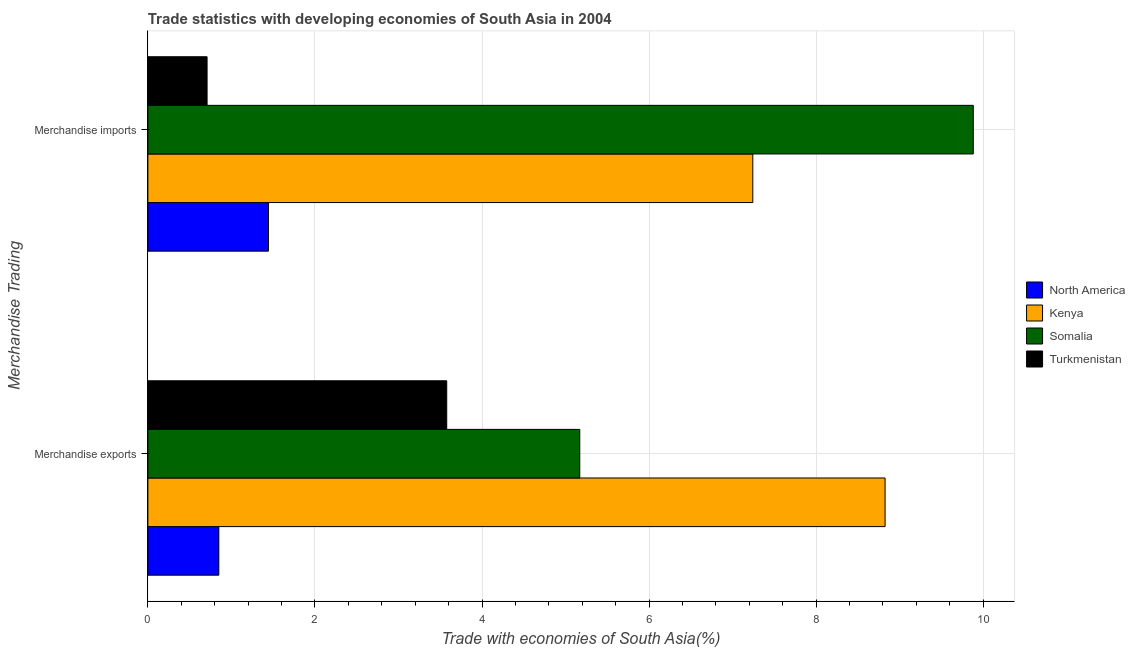How many different coloured bars are there?
Give a very brief answer. 4. How many groups of bars are there?
Make the answer very short. 2. How many bars are there on the 2nd tick from the bottom?
Offer a terse response. 4. What is the label of the 2nd group of bars from the top?
Make the answer very short. Merchandise exports. What is the merchandise exports in Turkmenistan?
Your answer should be very brief. 3.58. Across all countries, what is the maximum merchandise imports?
Give a very brief answer. 9.88. Across all countries, what is the minimum merchandise imports?
Offer a terse response. 0.71. In which country was the merchandise imports maximum?
Keep it short and to the point. Somalia. In which country was the merchandise imports minimum?
Make the answer very short. Turkmenistan. What is the total merchandise exports in the graph?
Provide a short and direct response. 18.42. What is the difference between the merchandise exports in Kenya and that in Somalia?
Provide a short and direct response. 3.65. What is the difference between the merchandise imports in North America and the merchandise exports in Turkmenistan?
Provide a short and direct response. -2.13. What is the average merchandise imports per country?
Offer a terse response. 4.82. What is the difference between the merchandise exports and merchandise imports in Somalia?
Give a very brief answer. -4.71. In how many countries, is the merchandise imports greater than 4.4 %?
Offer a very short reply. 2. What is the ratio of the merchandise exports in Kenya to that in Turkmenistan?
Keep it short and to the point. 2.47. Is the merchandise imports in Kenya less than that in North America?
Your answer should be very brief. No. What does the 4th bar from the bottom in Merchandise imports represents?
Your answer should be very brief. Turkmenistan. What is the difference between two consecutive major ticks on the X-axis?
Your answer should be very brief. 2. Does the graph contain any zero values?
Offer a very short reply. No. Does the graph contain grids?
Ensure brevity in your answer.  Yes. Where does the legend appear in the graph?
Keep it short and to the point. Center right. How many legend labels are there?
Your answer should be very brief. 4. What is the title of the graph?
Offer a terse response. Trade statistics with developing economies of South Asia in 2004. What is the label or title of the X-axis?
Your answer should be very brief. Trade with economies of South Asia(%). What is the label or title of the Y-axis?
Offer a terse response. Merchandise Trading. What is the Trade with economies of South Asia(%) of North America in Merchandise exports?
Your answer should be compact. 0.85. What is the Trade with economies of South Asia(%) of Kenya in Merchandise exports?
Provide a short and direct response. 8.83. What is the Trade with economies of South Asia(%) in Somalia in Merchandise exports?
Your response must be concise. 5.17. What is the Trade with economies of South Asia(%) of Turkmenistan in Merchandise exports?
Provide a succinct answer. 3.58. What is the Trade with economies of South Asia(%) in North America in Merchandise imports?
Your answer should be compact. 1.44. What is the Trade with economies of South Asia(%) in Kenya in Merchandise imports?
Your answer should be very brief. 7.24. What is the Trade with economies of South Asia(%) in Somalia in Merchandise imports?
Provide a succinct answer. 9.88. What is the Trade with economies of South Asia(%) in Turkmenistan in Merchandise imports?
Provide a succinct answer. 0.71. Across all Merchandise Trading, what is the maximum Trade with economies of South Asia(%) in North America?
Your response must be concise. 1.44. Across all Merchandise Trading, what is the maximum Trade with economies of South Asia(%) of Kenya?
Offer a terse response. 8.83. Across all Merchandise Trading, what is the maximum Trade with economies of South Asia(%) of Somalia?
Offer a terse response. 9.88. Across all Merchandise Trading, what is the maximum Trade with economies of South Asia(%) of Turkmenistan?
Your answer should be compact. 3.58. Across all Merchandise Trading, what is the minimum Trade with economies of South Asia(%) in North America?
Offer a terse response. 0.85. Across all Merchandise Trading, what is the minimum Trade with economies of South Asia(%) in Kenya?
Keep it short and to the point. 7.24. Across all Merchandise Trading, what is the minimum Trade with economies of South Asia(%) of Somalia?
Your response must be concise. 5.17. Across all Merchandise Trading, what is the minimum Trade with economies of South Asia(%) of Turkmenistan?
Ensure brevity in your answer.  0.71. What is the total Trade with economies of South Asia(%) in North America in the graph?
Provide a succinct answer. 2.29. What is the total Trade with economies of South Asia(%) of Kenya in the graph?
Offer a very short reply. 16.07. What is the total Trade with economies of South Asia(%) of Somalia in the graph?
Offer a very short reply. 15.05. What is the total Trade with economies of South Asia(%) in Turkmenistan in the graph?
Your answer should be compact. 4.29. What is the difference between the Trade with economies of South Asia(%) in North America in Merchandise exports and that in Merchandise imports?
Offer a very short reply. -0.59. What is the difference between the Trade with economies of South Asia(%) of Kenya in Merchandise exports and that in Merchandise imports?
Ensure brevity in your answer.  1.58. What is the difference between the Trade with economies of South Asia(%) in Somalia in Merchandise exports and that in Merchandise imports?
Your response must be concise. -4.71. What is the difference between the Trade with economies of South Asia(%) of Turkmenistan in Merchandise exports and that in Merchandise imports?
Give a very brief answer. 2.87. What is the difference between the Trade with economies of South Asia(%) in North America in Merchandise exports and the Trade with economies of South Asia(%) in Kenya in Merchandise imports?
Your answer should be compact. -6.39. What is the difference between the Trade with economies of South Asia(%) in North America in Merchandise exports and the Trade with economies of South Asia(%) in Somalia in Merchandise imports?
Offer a terse response. -9.03. What is the difference between the Trade with economies of South Asia(%) of North America in Merchandise exports and the Trade with economies of South Asia(%) of Turkmenistan in Merchandise imports?
Offer a very short reply. 0.14. What is the difference between the Trade with economies of South Asia(%) in Kenya in Merchandise exports and the Trade with economies of South Asia(%) in Somalia in Merchandise imports?
Provide a short and direct response. -1.06. What is the difference between the Trade with economies of South Asia(%) in Kenya in Merchandise exports and the Trade with economies of South Asia(%) in Turkmenistan in Merchandise imports?
Provide a short and direct response. 8.12. What is the difference between the Trade with economies of South Asia(%) in Somalia in Merchandise exports and the Trade with economies of South Asia(%) in Turkmenistan in Merchandise imports?
Provide a succinct answer. 4.46. What is the average Trade with economies of South Asia(%) of North America per Merchandise Trading?
Your response must be concise. 1.15. What is the average Trade with economies of South Asia(%) in Kenya per Merchandise Trading?
Make the answer very short. 8.03. What is the average Trade with economies of South Asia(%) of Somalia per Merchandise Trading?
Provide a succinct answer. 7.53. What is the average Trade with economies of South Asia(%) in Turkmenistan per Merchandise Trading?
Offer a very short reply. 2.14. What is the difference between the Trade with economies of South Asia(%) in North America and Trade with economies of South Asia(%) in Kenya in Merchandise exports?
Provide a short and direct response. -7.98. What is the difference between the Trade with economies of South Asia(%) of North America and Trade with economies of South Asia(%) of Somalia in Merchandise exports?
Your response must be concise. -4.32. What is the difference between the Trade with economies of South Asia(%) in North America and Trade with economies of South Asia(%) in Turkmenistan in Merchandise exports?
Keep it short and to the point. -2.73. What is the difference between the Trade with economies of South Asia(%) of Kenya and Trade with economies of South Asia(%) of Somalia in Merchandise exports?
Your answer should be very brief. 3.65. What is the difference between the Trade with economies of South Asia(%) in Kenya and Trade with economies of South Asia(%) in Turkmenistan in Merchandise exports?
Make the answer very short. 5.25. What is the difference between the Trade with economies of South Asia(%) of Somalia and Trade with economies of South Asia(%) of Turkmenistan in Merchandise exports?
Provide a short and direct response. 1.59. What is the difference between the Trade with economies of South Asia(%) in North America and Trade with economies of South Asia(%) in Kenya in Merchandise imports?
Give a very brief answer. -5.8. What is the difference between the Trade with economies of South Asia(%) in North America and Trade with economies of South Asia(%) in Somalia in Merchandise imports?
Provide a short and direct response. -8.44. What is the difference between the Trade with economies of South Asia(%) of North America and Trade with economies of South Asia(%) of Turkmenistan in Merchandise imports?
Your response must be concise. 0.73. What is the difference between the Trade with economies of South Asia(%) of Kenya and Trade with economies of South Asia(%) of Somalia in Merchandise imports?
Ensure brevity in your answer.  -2.64. What is the difference between the Trade with economies of South Asia(%) in Kenya and Trade with economies of South Asia(%) in Turkmenistan in Merchandise imports?
Give a very brief answer. 6.53. What is the difference between the Trade with economies of South Asia(%) in Somalia and Trade with economies of South Asia(%) in Turkmenistan in Merchandise imports?
Offer a terse response. 9.17. What is the ratio of the Trade with economies of South Asia(%) in North America in Merchandise exports to that in Merchandise imports?
Your response must be concise. 0.59. What is the ratio of the Trade with economies of South Asia(%) of Kenya in Merchandise exports to that in Merchandise imports?
Your answer should be compact. 1.22. What is the ratio of the Trade with economies of South Asia(%) in Somalia in Merchandise exports to that in Merchandise imports?
Offer a terse response. 0.52. What is the ratio of the Trade with economies of South Asia(%) of Turkmenistan in Merchandise exports to that in Merchandise imports?
Keep it short and to the point. 5.05. What is the difference between the highest and the second highest Trade with economies of South Asia(%) in North America?
Your answer should be very brief. 0.59. What is the difference between the highest and the second highest Trade with economies of South Asia(%) in Kenya?
Your response must be concise. 1.58. What is the difference between the highest and the second highest Trade with economies of South Asia(%) of Somalia?
Give a very brief answer. 4.71. What is the difference between the highest and the second highest Trade with economies of South Asia(%) in Turkmenistan?
Provide a short and direct response. 2.87. What is the difference between the highest and the lowest Trade with economies of South Asia(%) in North America?
Make the answer very short. 0.59. What is the difference between the highest and the lowest Trade with economies of South Asia(%) of Kenya?
Your answer should be very brief. 1.58. What is the difference between the highest and the lowest Trade with economies of South Asia(%) of Somalia?
Give a very brief answer. 4.71. What is the difference between the highest and the lowest Trade with economies of South Asia(%) in Turkmenistan?
Provide a succinct answer. 2.87. 